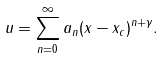<formula> <loc_0><loc_0><loc_500><loc_500>u = \sum _ { n = 0 } ^ { \infty } a _ { n } ( x - x _ { c } ) ^ { n + \gamma } .</formula> 